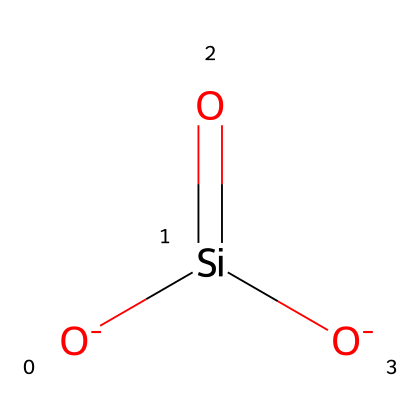How many oxygen atoms are present in the chemical? By examining the SMILES representation, we can see that there are two oxygen atoms indicated by [O-]. Each distinct [O] in the structure represents an oxygen atom.
Answer: two What is the central atom of this chemical? The central atom can be identified by looking for the atom that is connected to the most other atoms. In the provided SMILES, the silicon atom is represented by the notation [Si] and is the central atom connected to the two oxygen atoms.
Answer: silicon What type of bond connects silicon and oxygen in this chemical? In the provided SMILES, the connectivity between silicon and oxygen is indicated by the brackets and equals sign (=[O]). This notation shows that there is a double bond between silicon and the oxygen atom.
Answer: double bond How many total valence electrons are present in the molecule? To determine total valence electrons, we can add the valence electrons of each atom: Silicon (4) + 2 Oxygens (6 each) = 4 + 12 = 16 total valence electrons.
Answer: sixteen What is the charge of this chemical? The notation [O-] indicates both oxygen atoms carry a negative charge, giving the whole molecule an overall charge of -2 since there are two negatively charged oxygens and no positively charged elements to balance the charge.
Answer: negative two What might be a common application of this chemical structure in microcontrollers? Silica, which is composed of silicon and oxygen, is widely used in microelectronics and for insulating layers in microcontroller chips due to its semiconducting properties.
Answer: insulating layers 